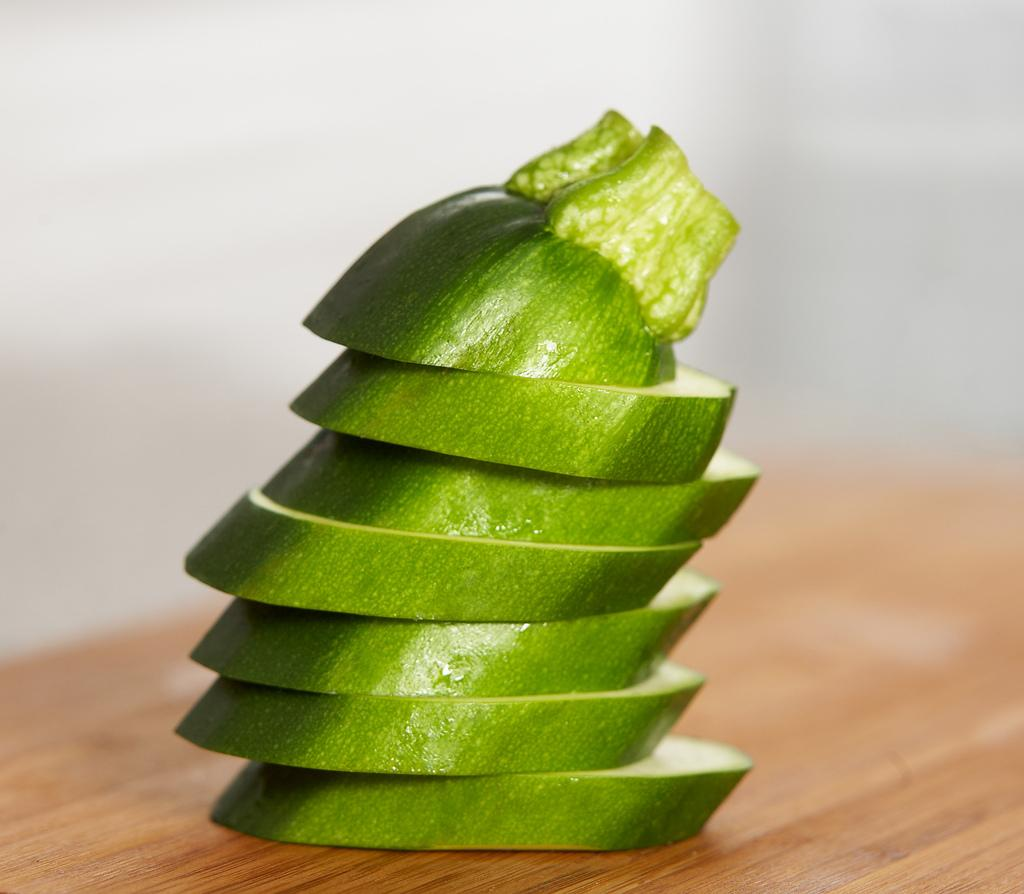What type of food can be seen in the image? There are cucumber slices in the image. On what surface are the cucumber slices placed? The cucumber slices are placed on a wooden surface. Can you describe the background of the image? The backdrop of the image is blurred. How many eyes can be seen on the hammer in the image? There is no hammer present in the image, and therefore no eyes can be seen on it. 